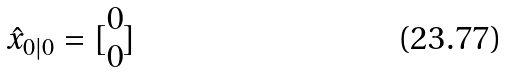Convert formula to latex. <formula><loc_0><loc_0><loc_500><loc_500>\hat { x } _ { 0 | 0 } = [ \begin{matrix} 0 \\ 0 \end{matrix} ]</formula> 